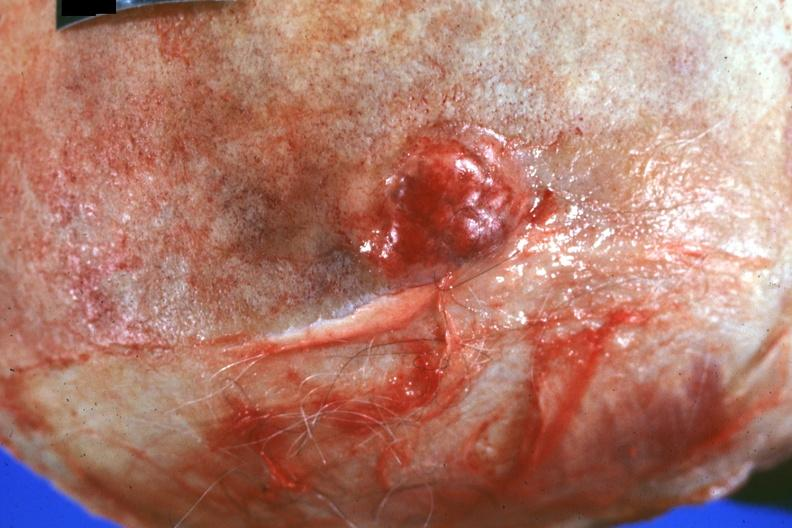what does this image show?
Answer the question using a single word or phrase. Close-up of obvious lesion primary in prostate 